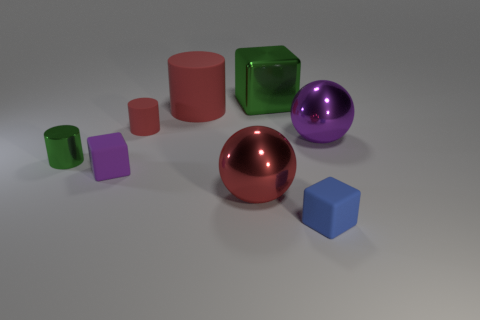How many other objects are the same color as the metal cylinder?
Make the answer very short. 1. There is a matte cube left of the tiny blue block; is its size the same as the red metallic sphere that is on the right side of the tiny red thing?
Keep it short and to the point. No. Is the number of big green metallic blocks right of the tiny metal cylinder the same as the number of purple shiny things that are in front of the blue rubber block?
Keep it short and to the point. No. Are there any other things that are the same material as the big purple thing?
Your response must be concise. Yes. There is a red metallic ball; is its size the same as the rubber object that is left of the small red cylinder?
Offer a very short reply. No. What material is the large object that is in front of the large sphere behind the small purple rubber thing?
Your answer should be compact. Metal. Are there the same number of small objects that are right of the small blue block and small purple matte things?
Provide a short and direct response. No. There is a cube that is to the right of the large red rubber object and on the left side of the tiny blue rubber block; what size is it?
Your response must be concise. Large. What is the color of the metal ball that is on the left side of the small block that is to the right of the large matte cylinder?
Keep it short and to the point. Red. How many green objects are tiny spheres or big things?
Your response must be concise. 1. 